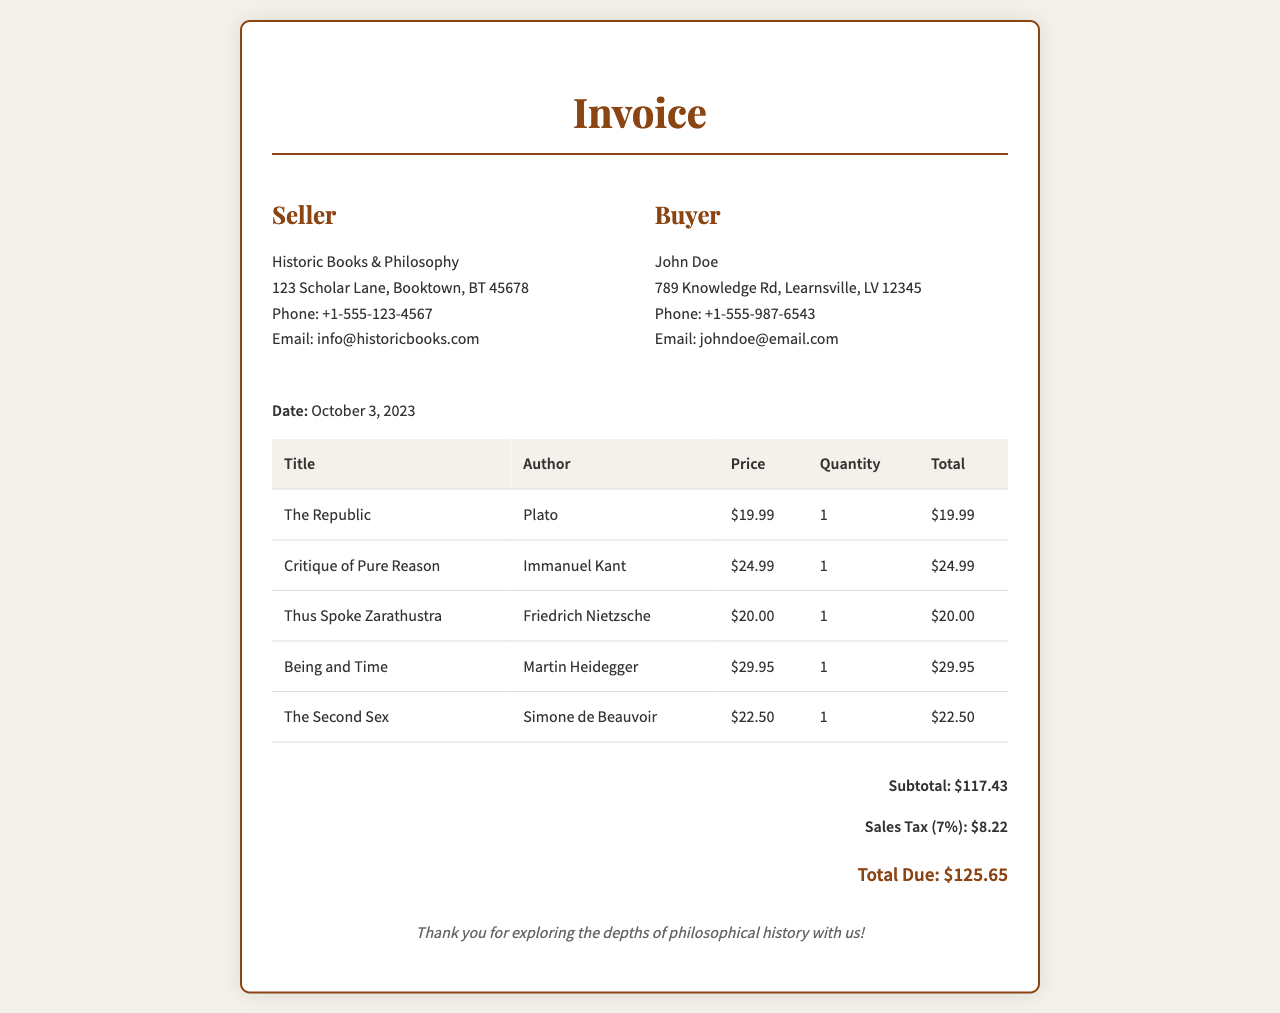What is the buyer's name? The buyer's name is listed in the document, which is John Doe.
Answer: John Doe What is the date of the invoice? The date of the invoice is given in the document as the specific date of purchase.
Answer: October 3, 2023 How many books did John Doe purchase? The document lists five individual book entries, and John Doe purchased one of each.
Answer: 5 What is the total due amount? The total due amount is calculated as the sum of subtotal and sales tax, clearly stated in the document.
Answer: $125.65 What is the sales tax percentage? The document specifies the sales tax rate applied to the subtotal amount.
Answer: 7% Who is the author of "Being and Time"? The document provides the title and corresponding author for each book purchased.
Answer: Martin Heidegger What is the subtotal amount before tax? The subtotal is clearly indicated in the document as the total of all items before adding sales tax.
Answer: $117.43 What is the price of "Thus Spoke Zarathustra"? The individual price of each book is stated in the document.
Answer: $20.00 